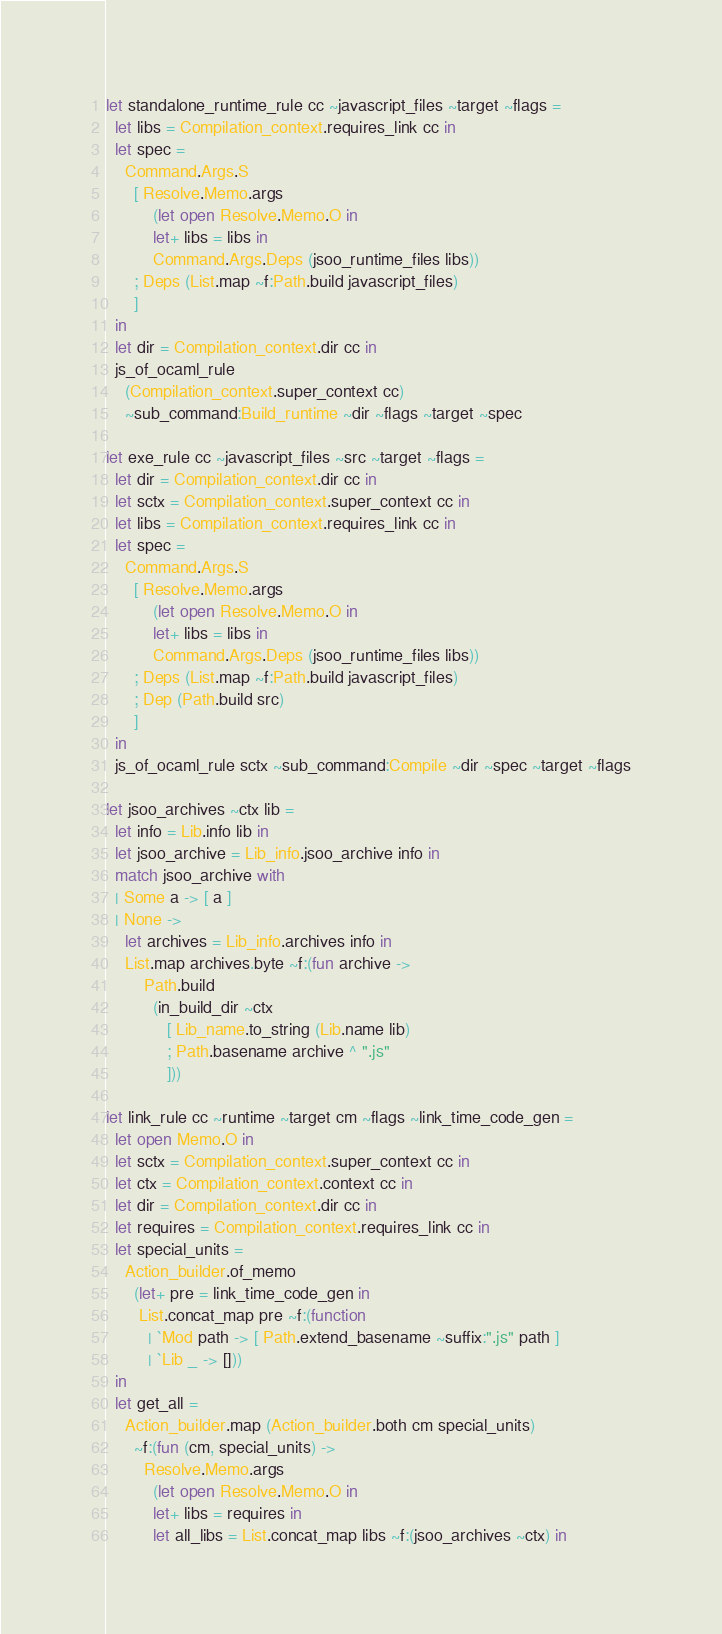<code> <loc_0><loc_0><loc_500><loc_500><_OCaml_>let standalone_runtime_rule cc ~javascript_files ~target ~flags =
  let libs = Compilation_context.requires_link cc in
  let spec =
    Command.Args.S
      [ Resolve.Memo.args
          (let open Resolve.Memo.O in
          let+ libs = libs in
          Command.Args.Deps (jsoo_runtime_files libs))
      ; Deps (List.map ~f:Path.build javascript_files)
      ]
  in
  let dir = Compilation_context.dir cc in
  js_of_ocaml_rule
    (Compilation_context.super_context cc)
    ~sub_command:Build_runtime ~dir ~flags ~target ~spec

let exe_rule cc ~javascript_files ~src ~target ~flags =
  let dir = Compilation_context.dir cc in
  let sctx = Compilation_context.super_context cc in
  let libs = Compilation_context.requires_link cc in
  let spec =
    Command.Args.S
      [ Resolve.Memo.args
          (let open Resolve.Memo.O in
          let+ libs = libs in
          Command.Args.Deps (jsoo_runtime_files libs))
      ; Deps (List.map ~f:Path.build javascript_files)
      ; Dep (Path.build src)
      ]
  in
  js_of_ocaml_rule sctx ~sub_command:Compile ~dir ~spec ~target ~flags

let jsoo_archives ~ctx lib =
  let info = Lib.info lib in
  let jsoo_archive = Lib_info.jsoo_archive info in
  match jsoo_archive with
  | Some a -> [ a ]
  | None ->
    let archives = Lib_info.archives info in
    List.map archives.byte ~f:(fun archive ->
        Path.build
          (in_build_dir ~ctx
             [ Lib_name.to_string (Lib.name lib)
             ; Path.basename archive ^ ".js"
             ]))

let link_rule cc ~runtime ~target cm ~flags ~link_time_code_gen =
  let open Memo.O in
  let sctx = Compilation_context.super_context cc in
  let ctx = Compilation_context.context cc in
  let dir = Compilation_context.dir cc in
  let requires = Compilation_context.requires_link cc in
  let special_units =
    Action_builder.of_memo
      (let+ pre = link_time_code_gen in
       List.concat_map pre ~f:(function
         | `Mod path -> [ Path.extend_basename ~suffix:".js" path ]
         | `Lib _ -> []))
  in
  let get_all =
    Action_builder.map (Action_builder.both cm special_units)
      ~f:(fun (cm, special_units) ->
        Resolve.Memo.args
          (let open Resolve.Memo.O in
          let+ libs = requires in
          let all_libs = List.concat_map libs ~f:(jsoo_archives ~ctx) in</code> 